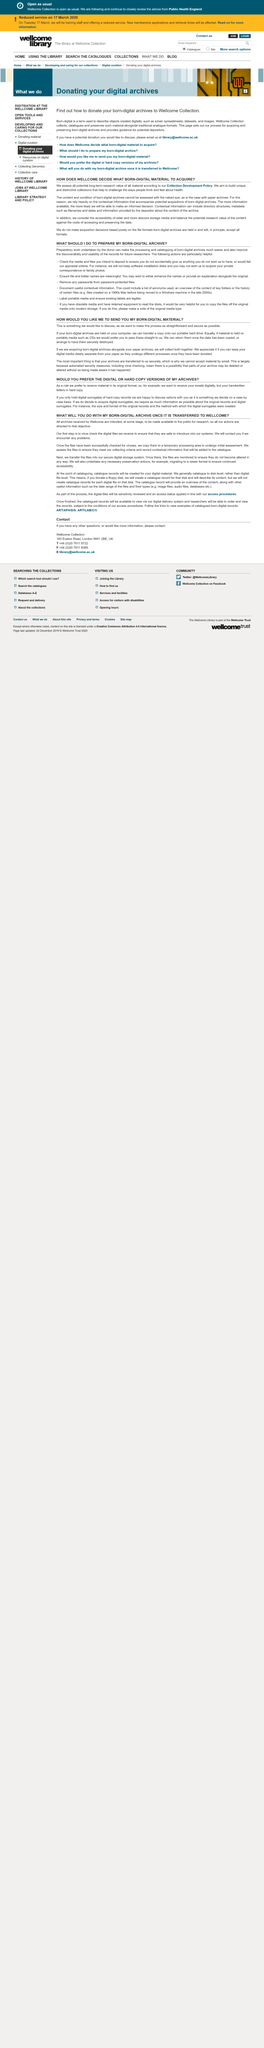Point out several critical features in this image. For digital surrogates to be acquired, it is necessary for us to have comprehensive information about the original records. The preferred method for receiving archives is via email, as digital copies, and hardcopy letters are received as physical documents. When your archive is received by Welcome, it will be made publicly available for research by the general public. I am writing to inquire about your preferred method of receiving digital materials that have been born in the current year. The term 'born-digital' refers to objects created digitally, such as those created using computers or other digital devices. 